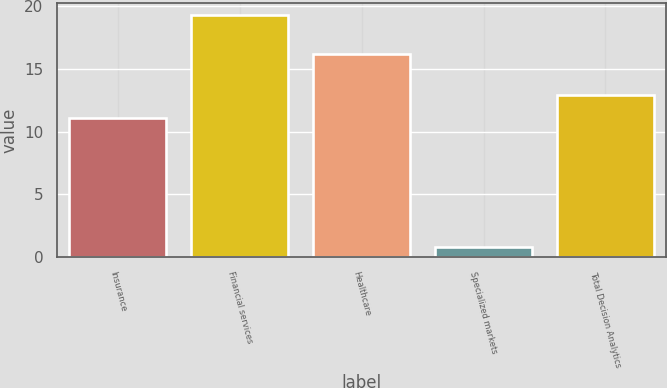Convert chart to OTSL. <chart><loc_0><loc_0><loc_500><loc_500><bar_chart><fcel>Insurance<fcel>Financial services<fcel>Healthcare<fcel>Specialized markets<fcel>Total Decision Analytics<nl><fcel>11.1<fcel>19.3<fcel>16.2<fcel>0.8<fcel>12.95<nl></chart> 